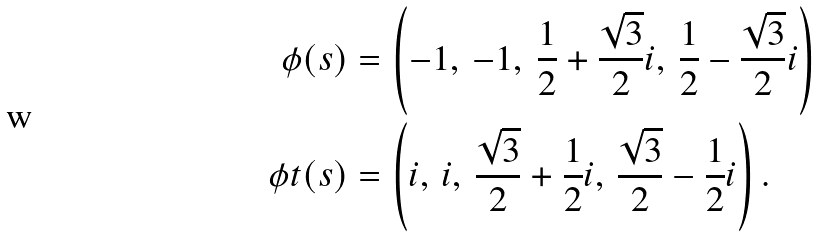Convert formula to latex. <formula><loc_0><loc_0><loc_500><loc_500>\phi ( s ) & = \left ( - 1 , \, - 1 , \, \frac { 1 } { 2 } + \frac { \sqrt { 3 } } 2 i , \, \frac { 1 } { 2 } - \frac { \sqrt { 3 } } 2 i \right ) \\ \phi t ( s ) & = \left ( i , \, i , \, \frac { \sqrt { 3 } } 2 + \frac { 1 } { 2 } i , \, \frac { \sqrt { 3 } } 2 - \frac { 1 } { 2 } i \right ) .</formula> 